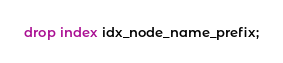Convert code to text. <code><loc_0><loc_0><loc_500><loc_500><_SQL_>drop index idx_node_name_prefix;
</code> 